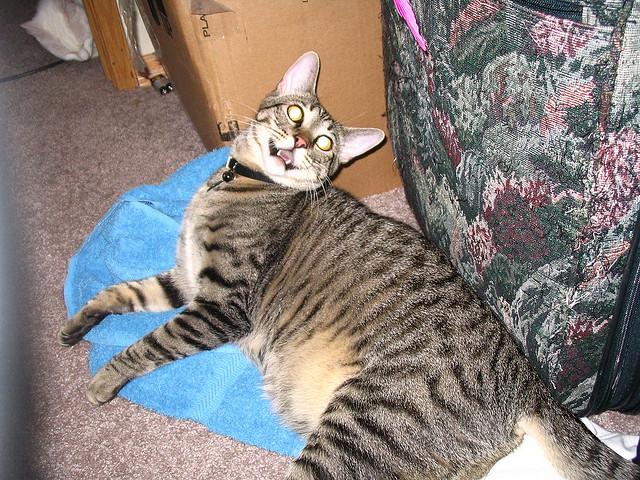What is the blue thing that the cat is laying on called?
Be succinct. Towel. Is this a wild cat?
Be succinct. No. Is there more than one cat in this shot?
Be succinct. No. What color is the carpet?
Short answer required. Brown. 